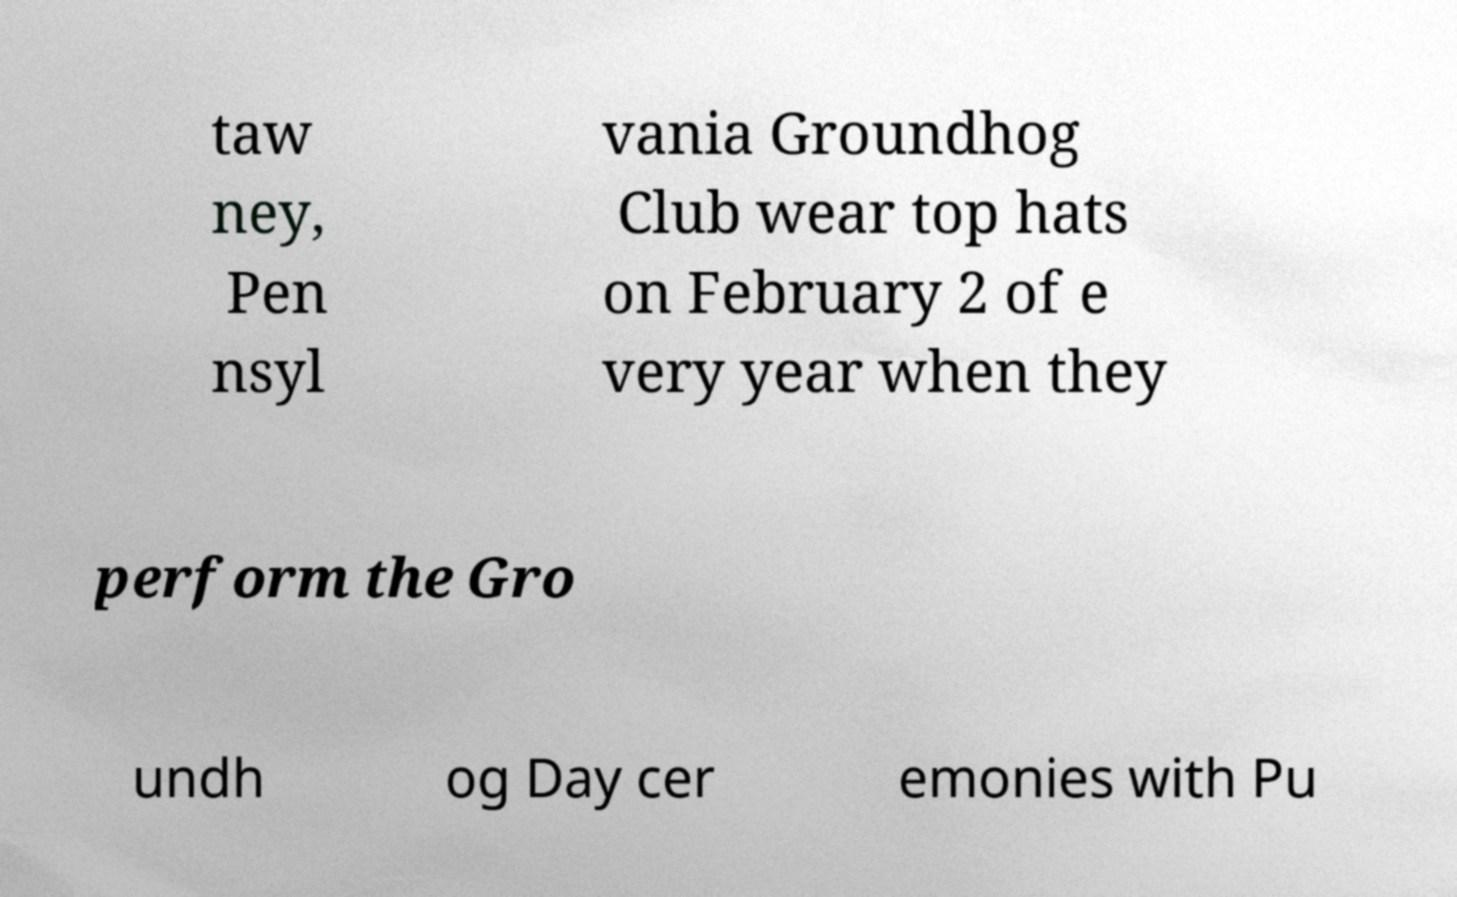I need the written content from this picture converted into text. Can you do that? taw ney, Pen nsyl vania Groundhog Club wear top hats on February 2 of e very year when they perform the Gro undh og Day cer emonies with Pu 